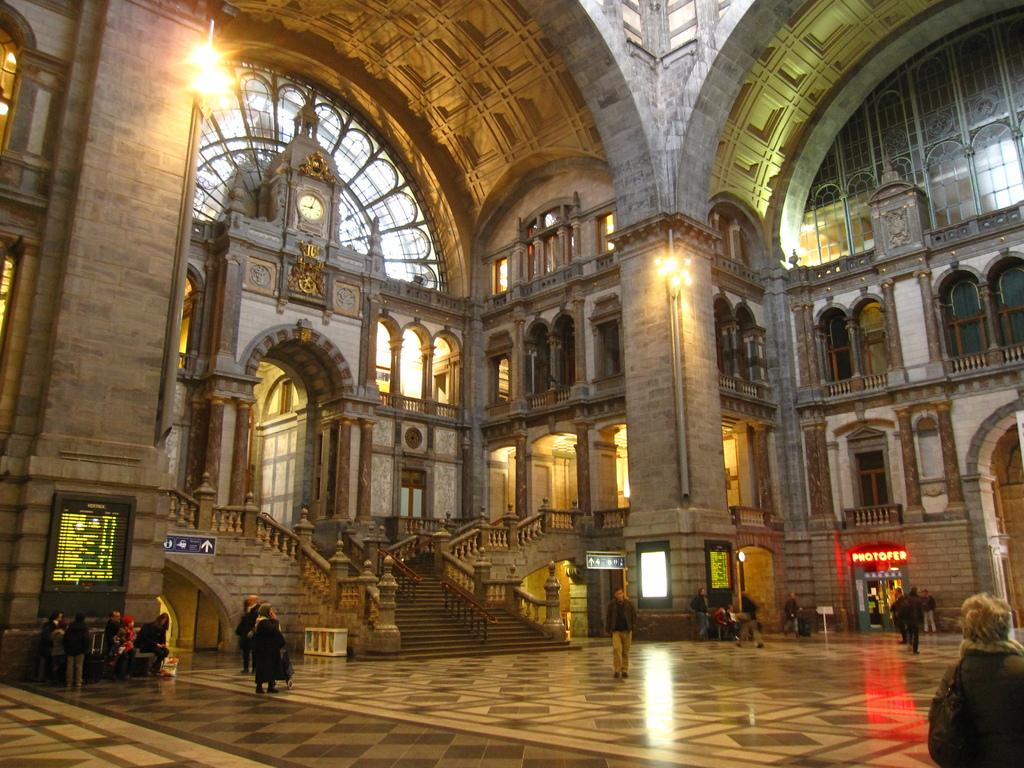What type of location is shown in the image? The image depicts an inside part of a fort. What can be seen in the middle of the image? There is a staircase in the middle of the image. Where are the people located in the image? There is a group of people on the left side of the image. What is visible at the top of the image? There are lights at the top of the image. Can you see a kitty playing with the moon in the image? There is no kitty or moon present in the image; it depicts an inside part of a fort with a staircase, people, and lights. 